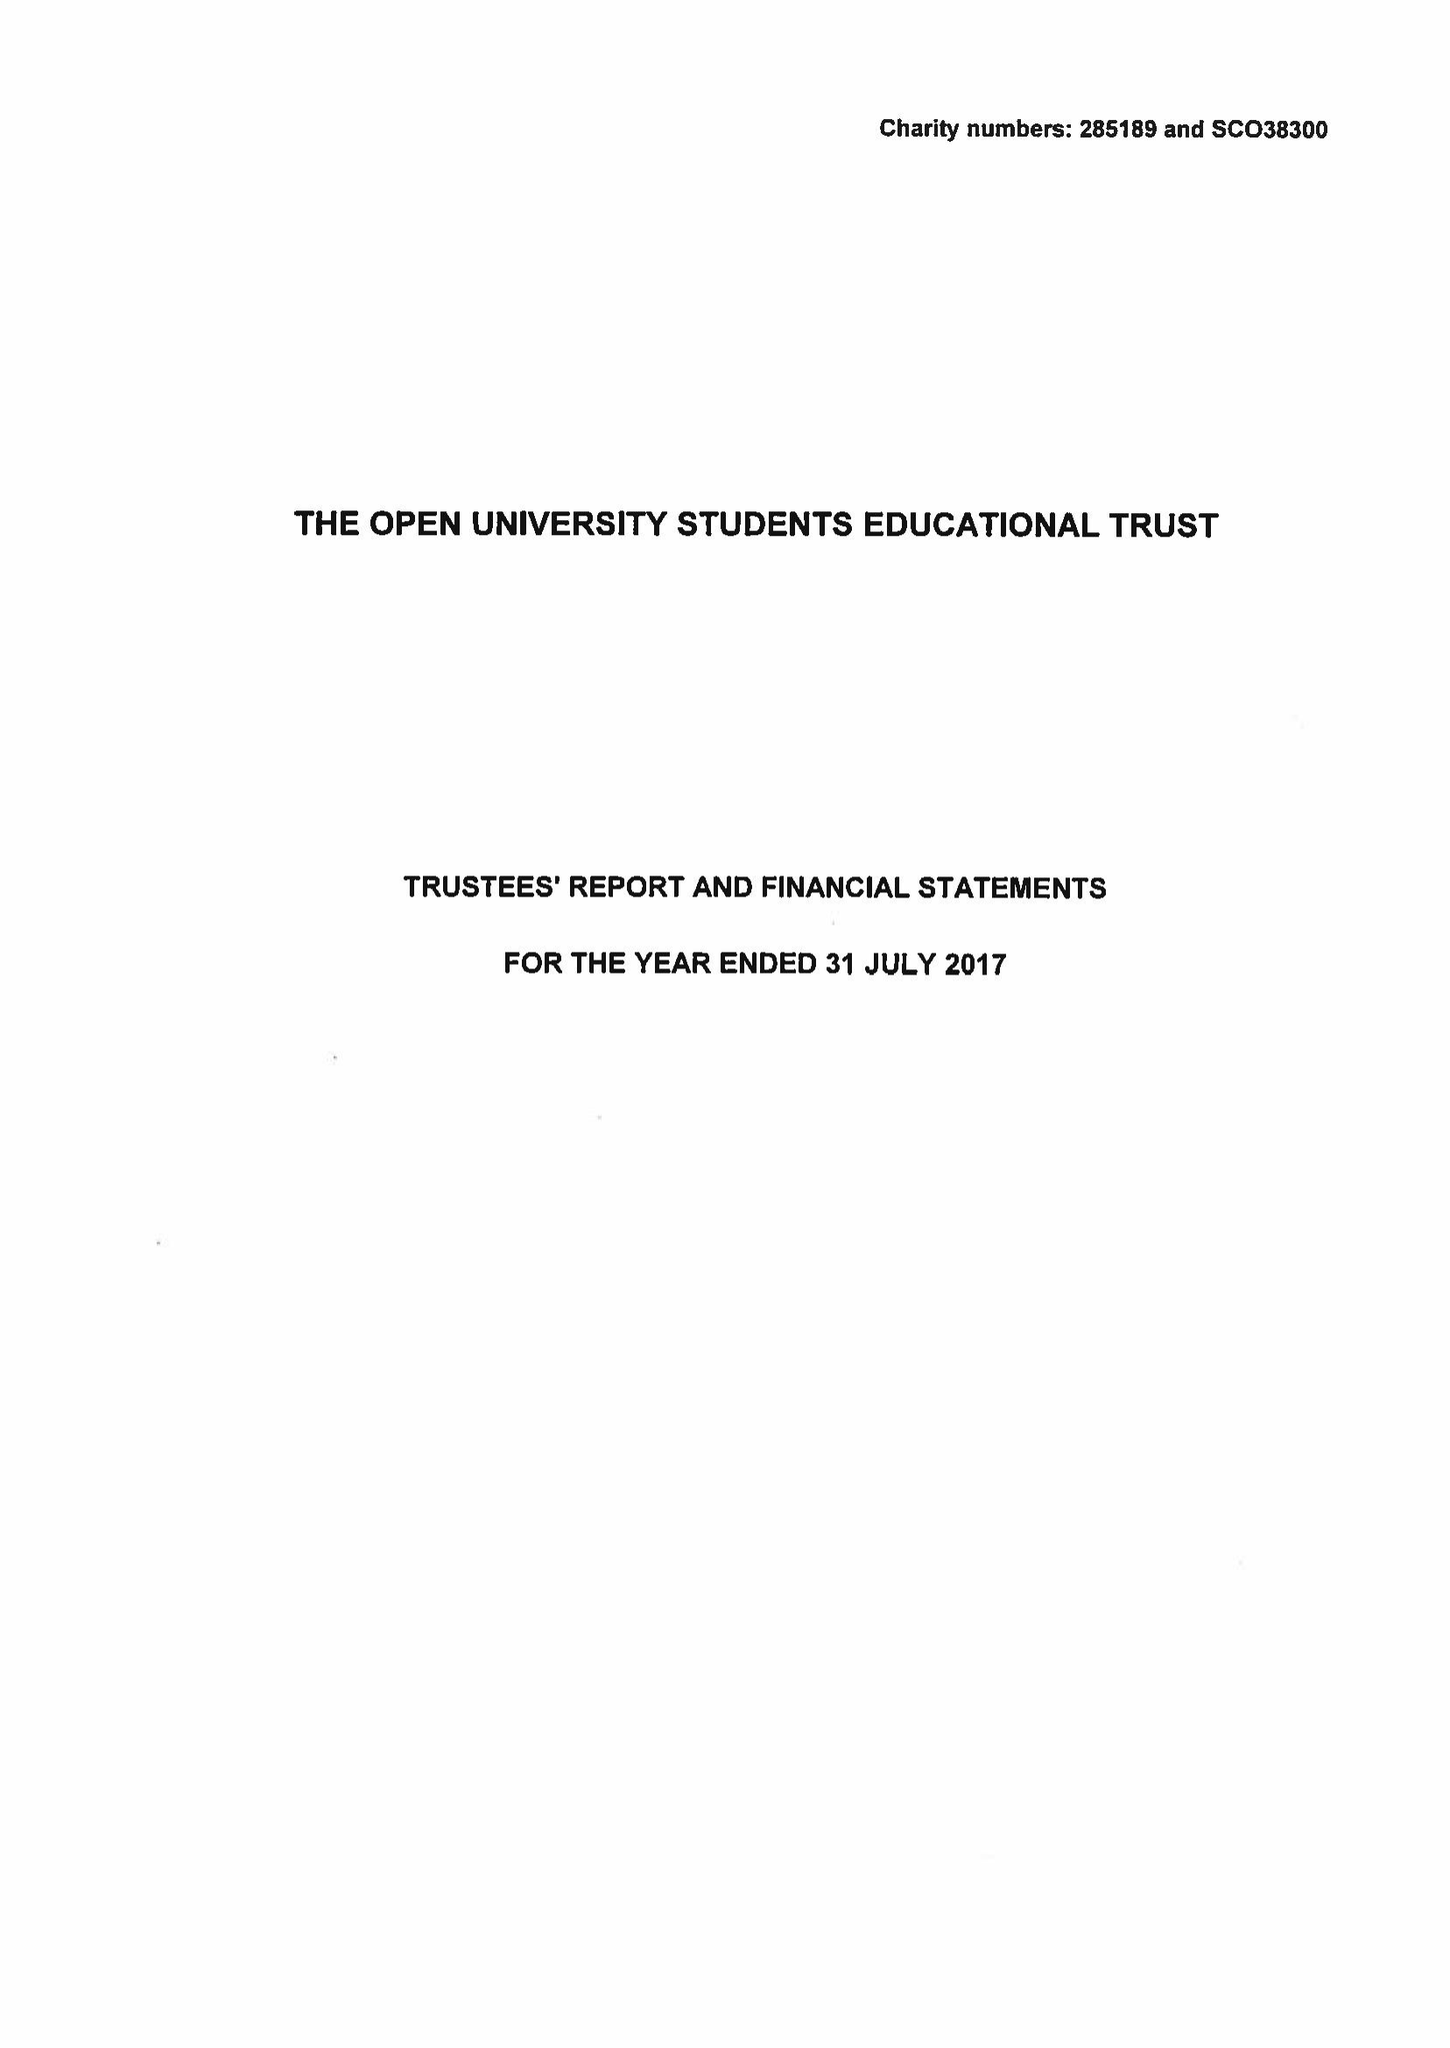What is the value for the report_date?
Answer the question using a single word or phrase. 2017-07-31 